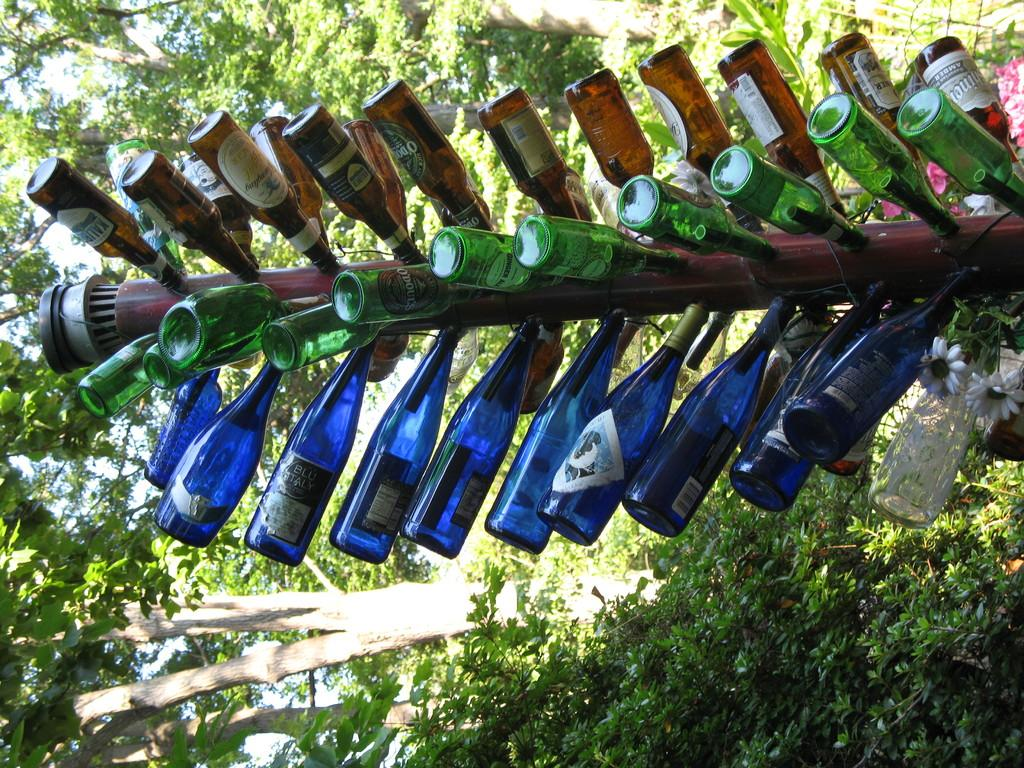What is the main subject in the image? There is a big pipeline in the image. What is attached to the pipeline? Bodies are fixed to the pipeline. What can be seen in the background of the image? There are trees visible in the background of the image. How many cabbages can be seen growing near the pipeline in the image? There are no cabbages visible in the image; it only features a big pipeline with bodies attached and trees in the background. 